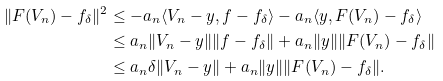<formula> <loc_0><loc_0><loc_500><loc_500>\| F ( V _ { n } ) - f _ { \delta } \| ^ { 2 } & \leq - a _ { n } \langle V _ { n } - y , f - f _ { \delta } \rangle - a _ { n } \langle y , F ( V _ { n } ) - f _ { \delta } \rangle \\ & \leq a _ { n } \| V _ { n } - y \| \| f - f _ { \delta } \| + a _ { n } \| y \| \| F ( V _ { n } ) - f _ { \delta } \| \\ & \leq a _ { n } \delta \| V _ { n } - y \| + a _ { n } \| y \| \| F ( V _ { n } ) - f _ { \delta } \| .</formula> 